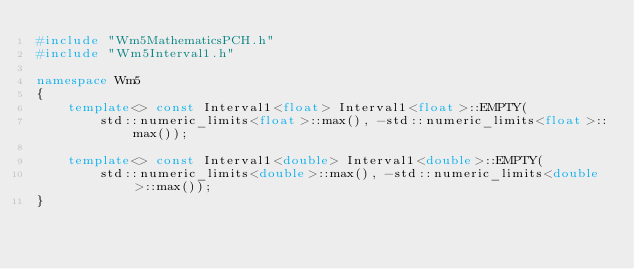<code> <loc_0><loc_0><loc_500><loc_500><_C++_>#include "Wm5MathematicsPCH.h"
#include "Wm5Interval1.h"

namespace Wm5
{
	template<> const Interval1<float> Interval1<float>::EMPTY(
		std::numeric_limits<float>::max(), -std::numeric_limits<float>::max());

	template<> const Interval1<double> Interval1<double>::EMPTY(
		std::numeric_limits<double>::max(), -std::numeric_limits<double>::max());
}
</code> 